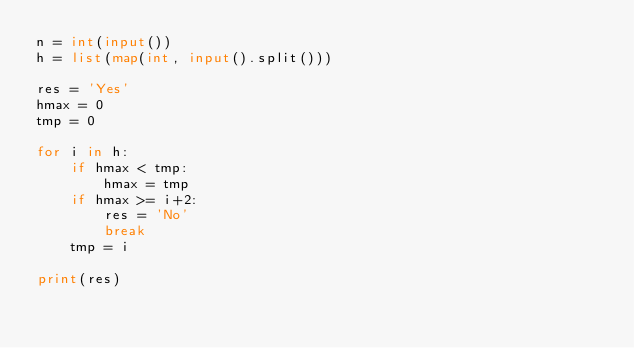<code> <loc_0><loc_0><loc_500><loc_500><_Python_>n = int(input())
h = list(map(int, input().split()))

res = 'Yes'
hmax = 0
tmp = 0

for i in h:
    if hmax < tmp:
        hmax = tmp
    if hmax >= i+2:
        res = 'No'
        break
    tmp = i

print(res)</code> 